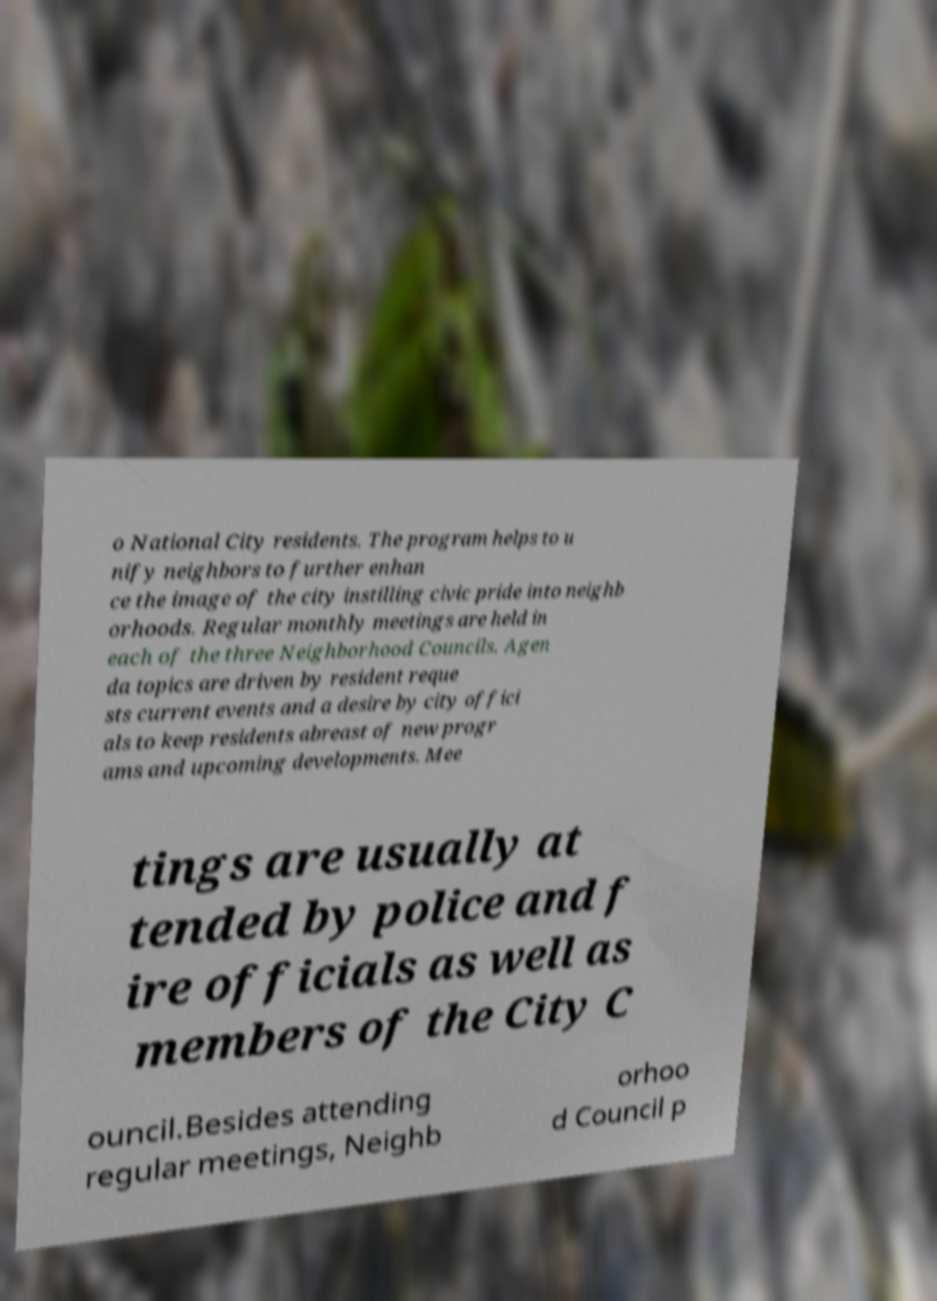Could you extract and type out the text from this image? o National City residents. The program helps to u nify neighbors to further enhan ce the image of the city instilling civic pride into neighb orhoods. Regular monthly meetings are held in each of the three Neighborhood Councils. Agen da topics are driven by resident reque sts current events and a desire by city offici als to keep residents abreast of new progr ams and upcoming developments. Mee tings are usually at tended by police and f ire officials as well as members of the City C ouncil.Besides attending regular meetings, Neighb orhoo d Council p 